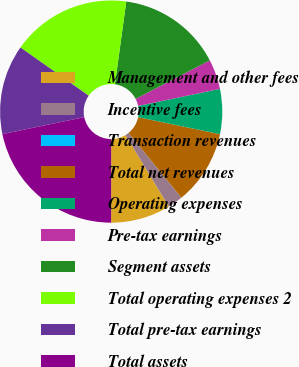Convert chart to OTSL. <chart><loc_0><loc_0><loc_500><loc_500><pie_chart><fcel>Management and other fees<fcel>Incentive fees<fcel>Transaction revenues<fcel>Total net revenues<fcel>Operating expenses<fcel>Pre-tax earnings<fcel>Segment assets<fcel>Total operating expenses 2<fcel>Total pre-tax earnings<fcel>Total assets<nl><fcel>8.7%<fcel>2.18%<fcel>0.01%<fcel>10.87%<fcel>6.53%<fcel>4.35%<fcel>15.21%<fcel>17.38%<fcel>13.04%<fcel>21.73%<nl></chart> 